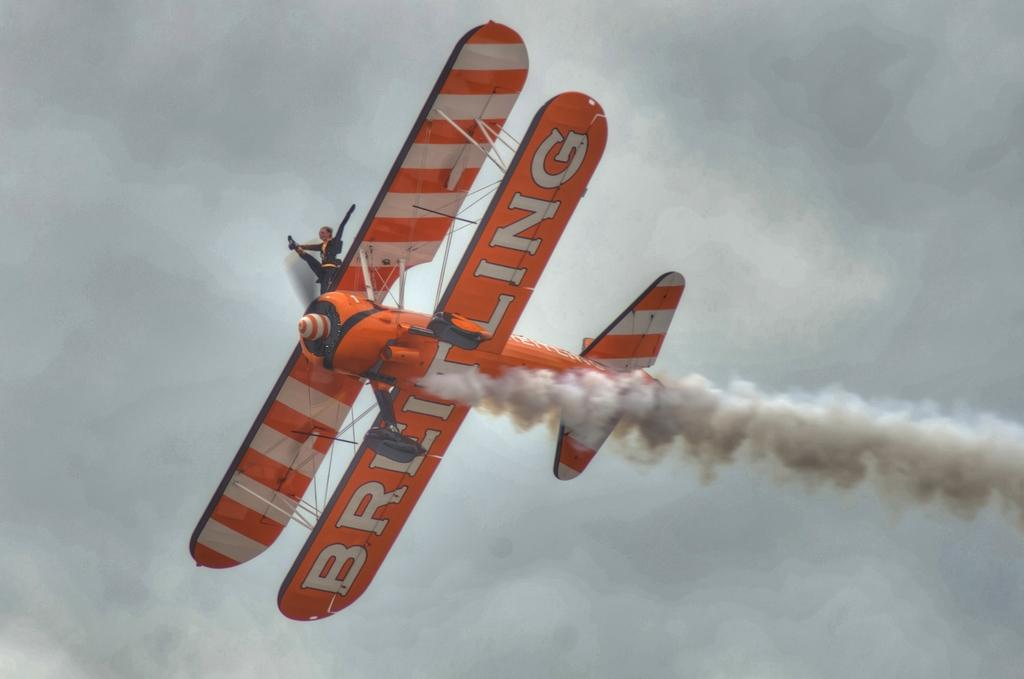<image>
Relay a brief, clear account of the picture shown. A Red Baron stunt plane flies through the air, billowing smoke,  with BREITLING displayed on it's wings, 